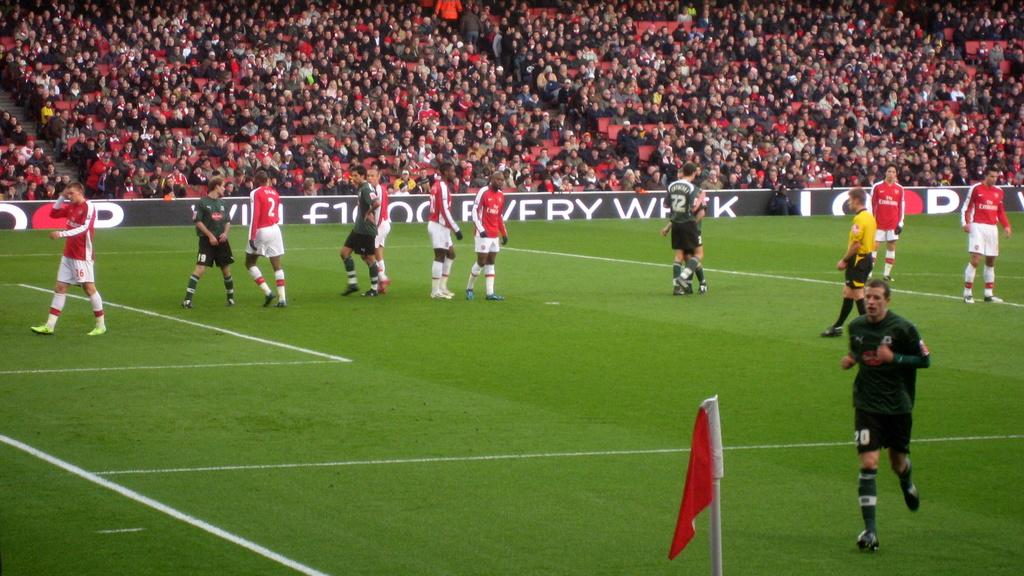Provide a one-sentence caption for the provided image. Number sixteen is walking down the field rubbing his head with his right hand. 